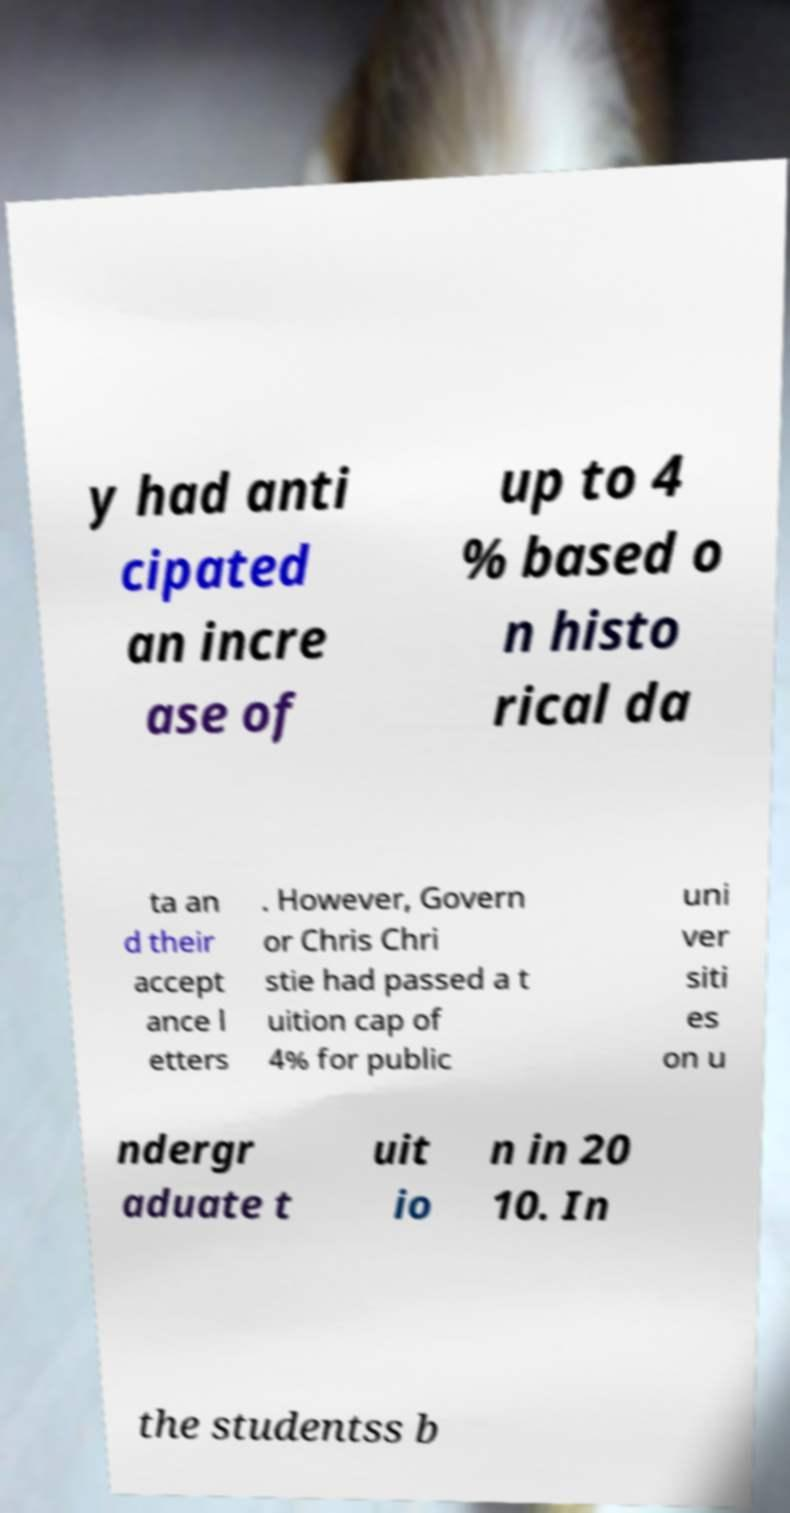Please identify and transcribe the text found in this image. y had anti cipated an incre ase of up to 4 % based o n histo rical da ta an d their accept ance l etters . However, Govern or Chris Chri stie had passed a t uition cap of 4% for public uni ver siti es on u ndergr aduate t uit io n in 20 10. In the studentss b 